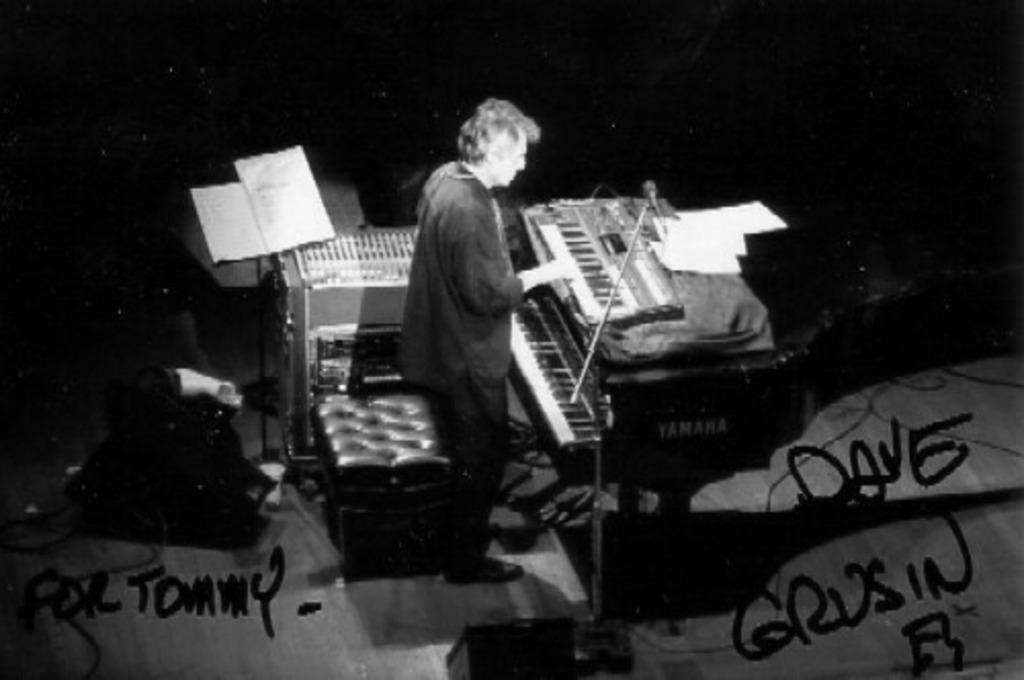What is the color scheme of the image? The image is black and white. Can you describe the main subject in the image? There is a person in the image. What can be seen in the background of the image? Papers and musical instruments are visible in the background of the image. Is there any text present in the image? Yes, there is some text in the image. Where is the box that the mother is holding in the image? There is no box or mother present in the image. What type of jewel is the person wearing in the image? There is no jewel visible on the person in the image. 